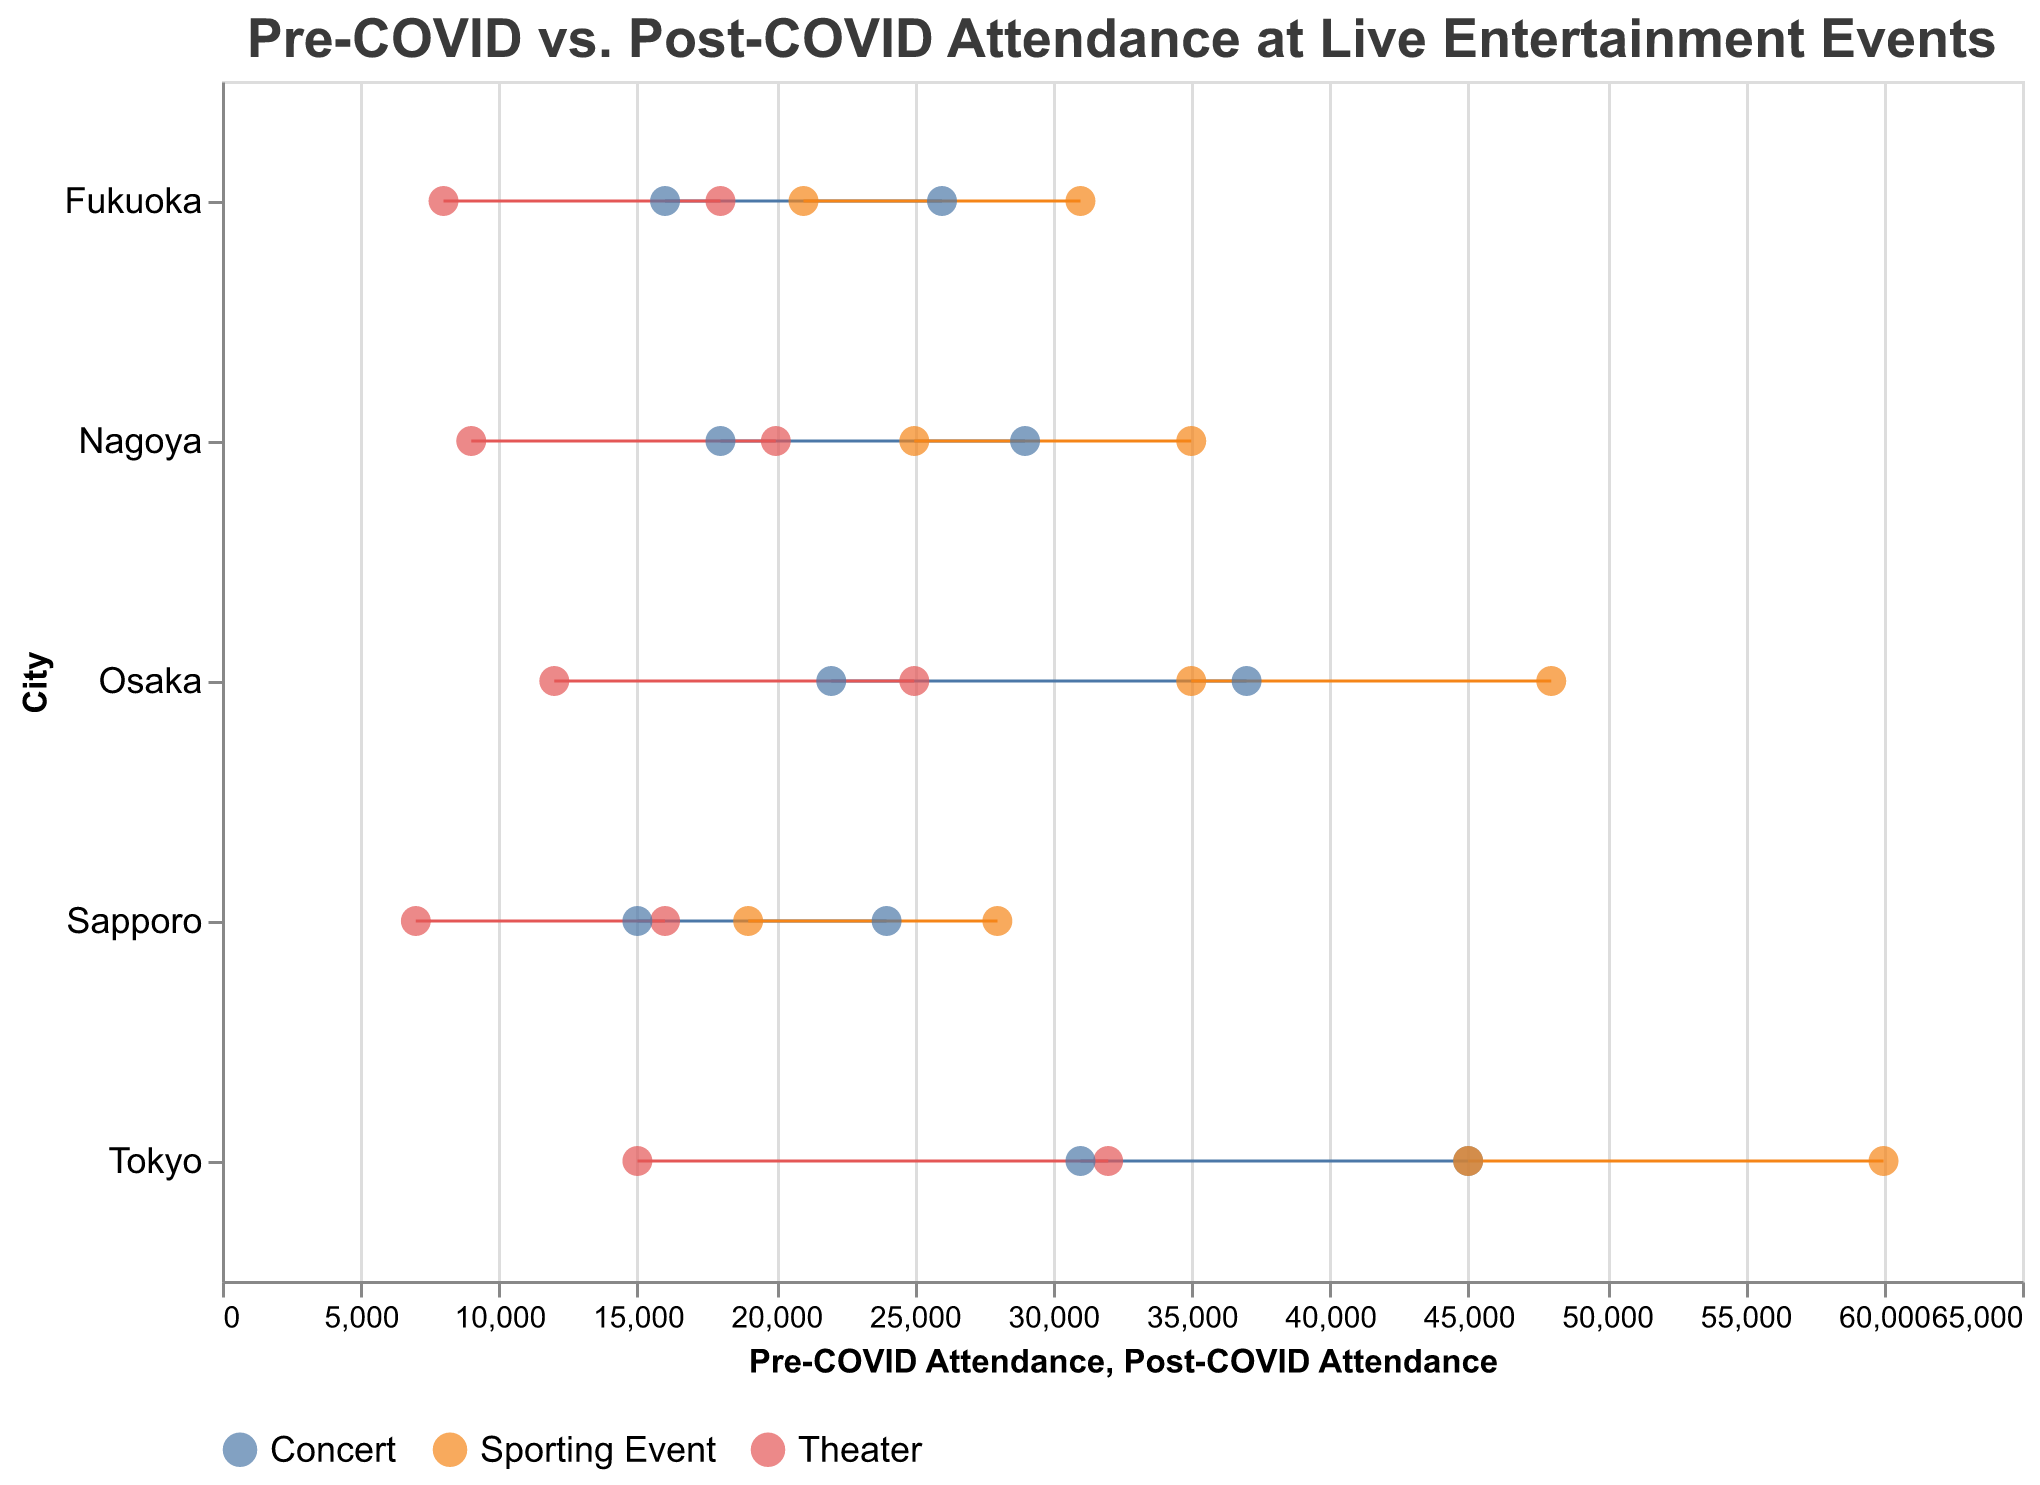Which city had the highest pre-COVID attendance for concerts? By looking at the point marked for pre-COVID attendance in the vertical axis against "City" and checking the "Concert" event type, we see the value. The highest attendance is in Tokyo with 45,000 attendees.
Answer: Tokyo What is the difference in post-COVID attendance for theaters between Osaka and Nagoya? Find the post-COVID attendance for theaters in Osaka and Nagoya, then subtract the smaller number from the larger. Osaka has 12,000 and Nagoya has 9,000, so the difference is 12,000 - 9,000 = 3,000.
Answer: 3,000 Which event type shows the smallest change in attendance in Fukuoka? Calculate the difference between pre-COVID and post-COVID attendance for each event type in Fukuoka. Concerts (26,000 - 16,000 = 10,000), Theater (18,000 - 8,000 = 10,000), and Sporting Events (31,000 - 21,000 = 10,000) all show a change of 10,000 attendees, so the smallest change is equal for all event types.
Answer: All event types, 10,000 How much has the attendance decreased on average for theaters across all cities post-COVID? First, find the individual attendance decreases for theaters in each city, then calculate the average. The decrease values are: Tokyo (32,000 - 15,000 = 17,000), Osaka (25,000 - 12,000 = 13,000), Nagoya (20,000 - 9,000 = 11,000), Fukuoka (18,000 - 8,000 = 10,000), Sapporo (16,000 - 7,000 = 9,000). The total decrease is 17,000 + 13,000 + 11,000 + 10,000 + 9,000 = 60,000. There are 5 cities, so the average decrease is 60,000 / 5 = 12,000.
Answer: 12,000 Which city experienced the largest decrease in concert attendance post-COVID? Measure the difference between pre- and post-COVID attendance for concerts in all cities, and find the largest. The values are Tokyo (45,000 - 31,000 = 14,000), Osaka (37,000 - 22,000 = 15,000), Nagoya (29,000 - 18,000 = 11,000), Fukuoka (26,000 - 16,000 = 10,000), Sapporo (24,000 - 15,000 = 9,000). Osaka shows the largest decrease of 15,000.
Answer: Osaka Are there any event types where post-COVID attendance is higher than pre-COVID? Review the dumbbell plot for all event types in all cities to see if any post-COVID attendance points are to the right of pre-COVID points. No event types have post-COVID attendance higher than pre-COVID attendance.
Answer: No How does the attendance for sporting events in Sapporo compare to Tokyo post-COVID? Compare the post-COVID attendance points for sporting events in Sapporo and Tokyo. Sapporo has 19,000 while Tokyo has 45,000, showing that Tokyo has higher post-COVID attendance.
Answer: Tokyo is higher What is the percentage decrease in attendance for theater events in Sapporo? Calculate the percentage decrease using the formula ((Pre-COVID - Post-COVID) / Pre-COVID) * 100. The attendance for Sapporo theaters decreased from 16,000 to 7,000. The percentage decrease is ((16,000 - 7,000) / 16,000) * 100 = 56.25%.
Answer: 56.25% Which city has the closest post-COVID concert attendance to 20,000? Check the post-COVID attendance for concerts in all cities and find the closest to 20,000. Osaka has 22,000 post-COVID concert attendance, which is the closest to 20,000.
Answer: Osaka 